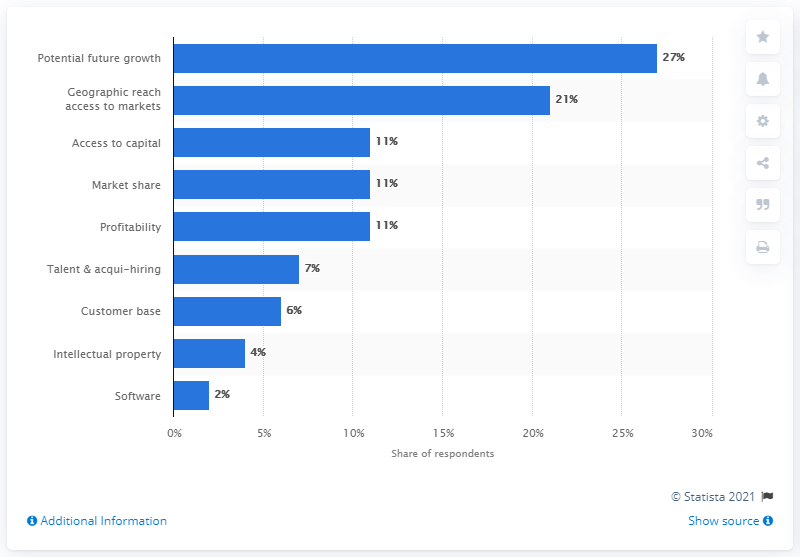Mention a couple of crucial points in this snapshot. According to the survey results, 27% of respondents identified the potential future growth of the target company as having the most significant impact on the valuation. 